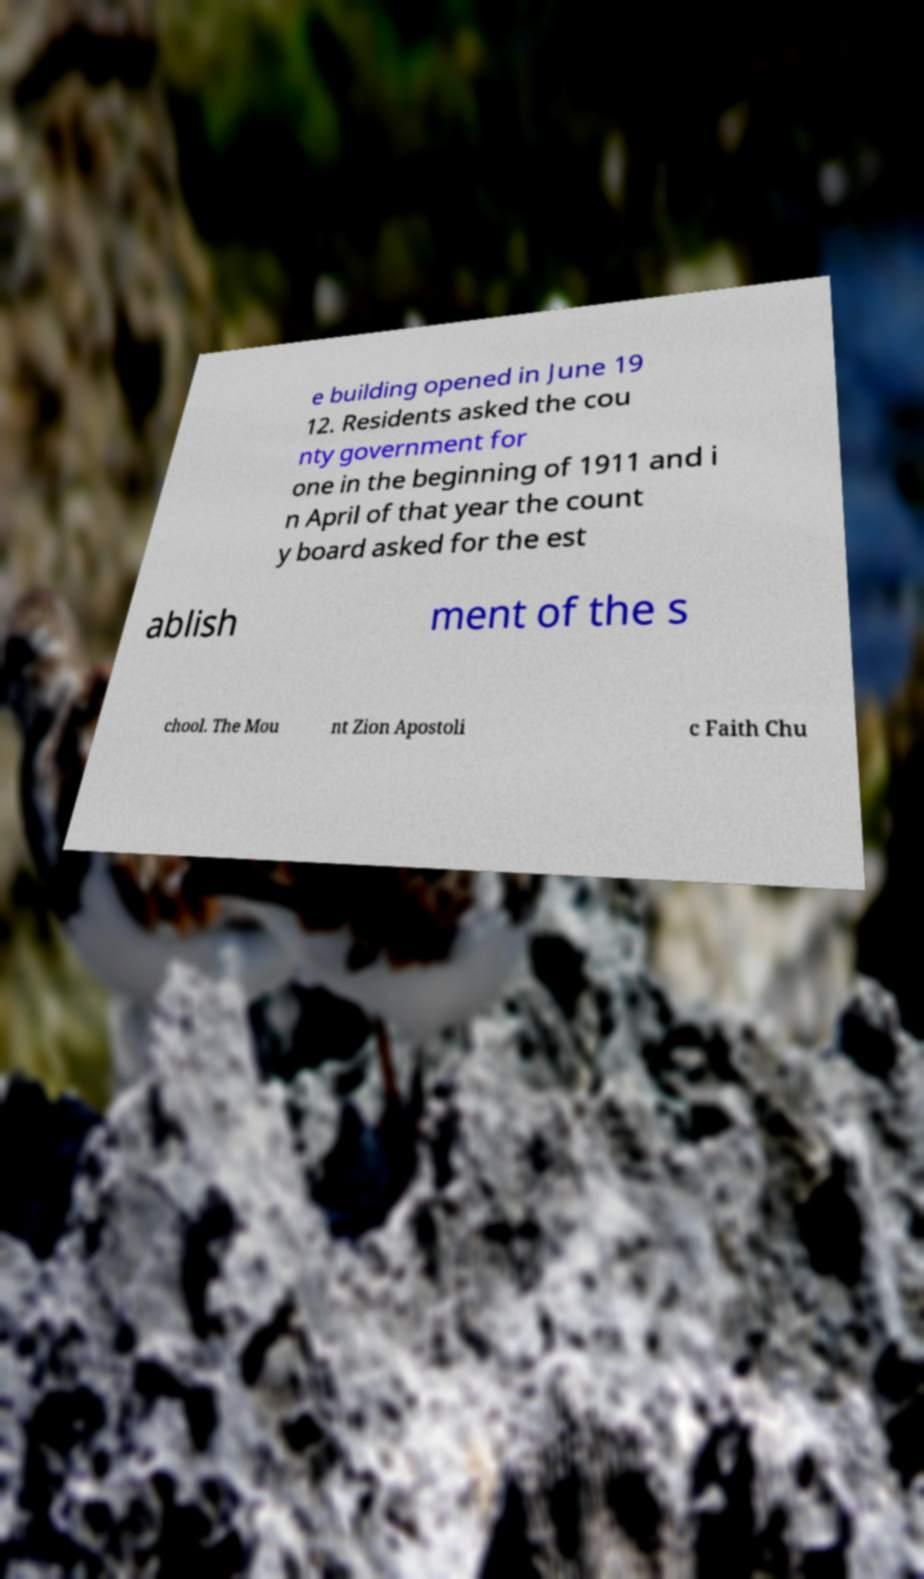What messages or text are displayed in this image? I need them in a readable, typed format. e building opened in June 19 12. Residents asked the cou nty government for one in the beginning of 1911 and i n April of that year the count y board asked for the est ablish ment of the s chool. The Mou nt Zion Apostoli c Faith Chu 